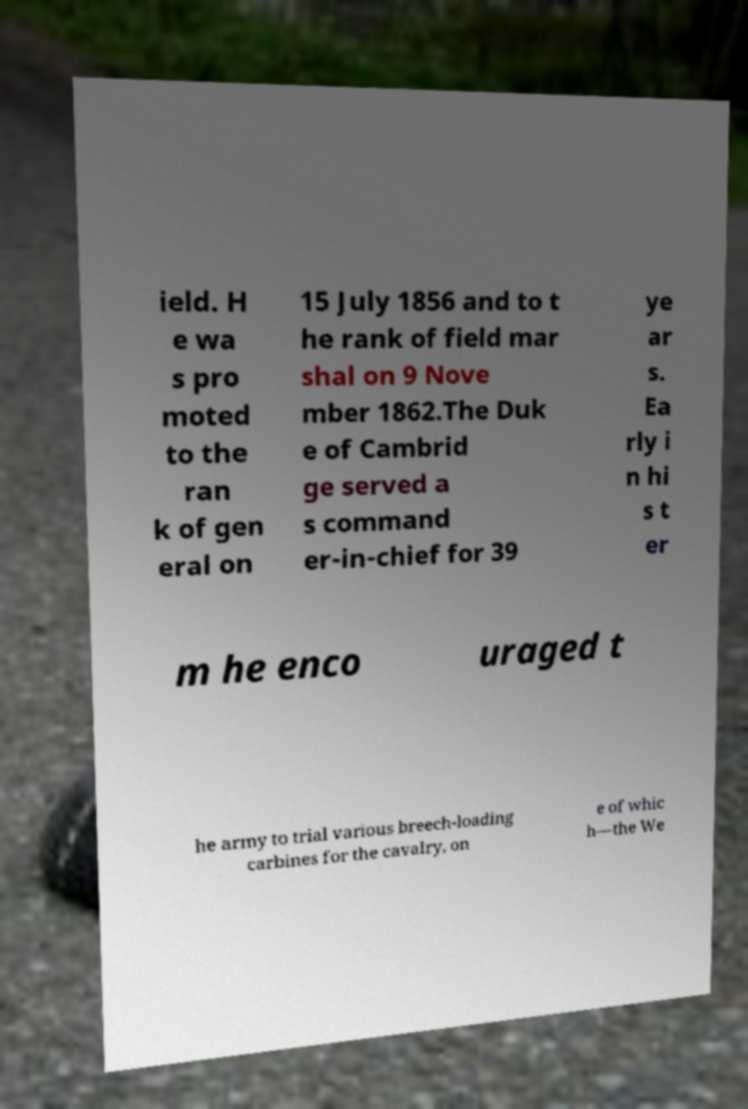I need the written content from this picture converted into text. Can you do that? ield. H e wa s pro moted to the ran k of gen eral on 15 July 1856 and to t he rank of field mar shal on 9 Nove mber 1862.The Duk e of Cambrid ge served a s command er-in-chief for 39 ye ar s. Ea rly i n hi s t er m he enco uraged t he army to trial various breech-loading carbines for the cavalry, on e of whic h—the We 